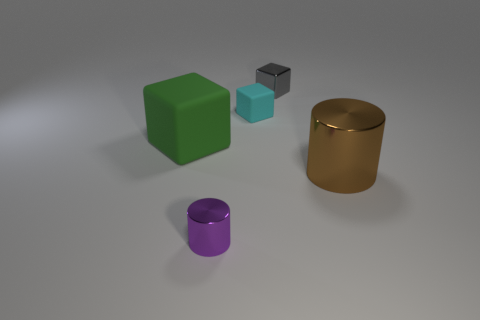Subtract all tiny metal blocks. How many blocks are left? 2 Add 3 big rubber things. How many objects exist? 8 Subtract all purple cylinders. How many cylinders are left? 1 Subtract 1 cubes. How many cubes are left? 2 Subtract all blue blocks. Subtract all cyan cylinders. How many blocks are left? 3 Subtract all cylinders. How many objects are left? 3 Subtract 0 yellow cylinders. How many objects are left? 5 Subtract all cyan objects. Subtract all big matte objects. How many objects are left? 3 Add 3 large green blocks. How many large green blocks are left? 4 Add 3 cyan rubber blocks. How many cyan rubber blocks exist? 4 